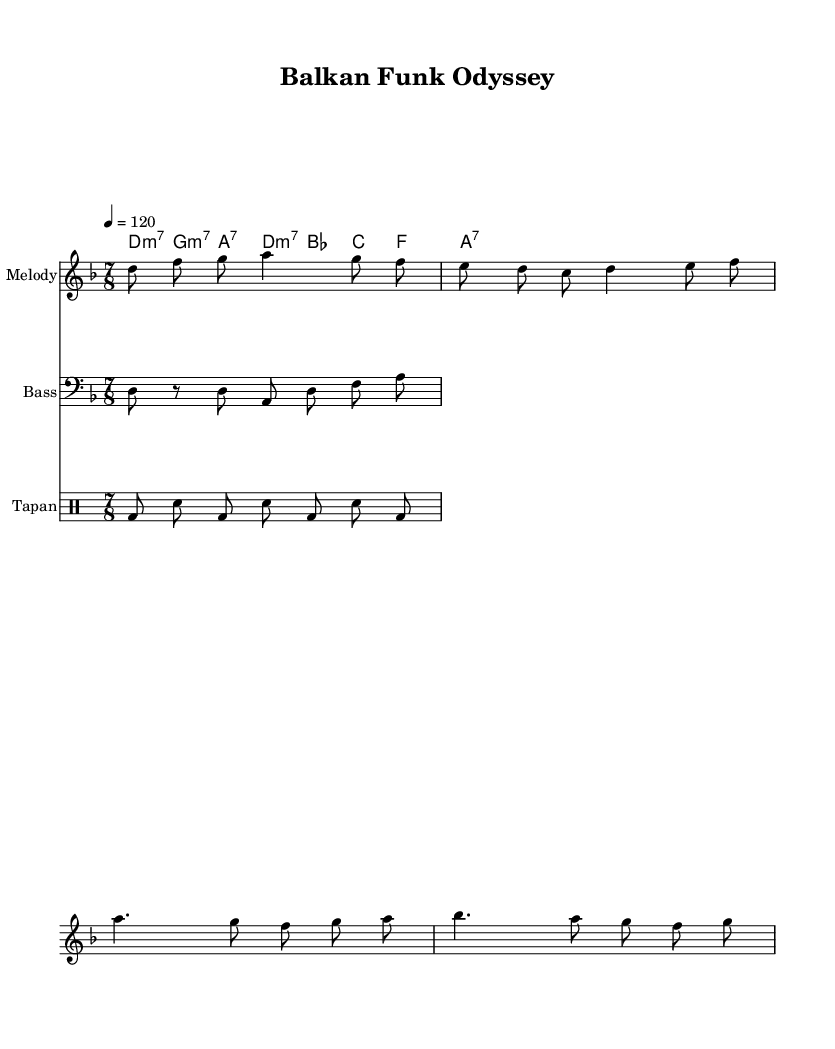What is the key signature of this music? The key signature indicated in the music is D minor, which typically has one flat (B flat) on the staff. This can be identified at the beginning of the score, where the sharps and flats are notated.
Answer: D minor What is the time signature of this piece? The time signature is shown as 7/8, which is specified in the beginning of the score. This indicates that there are seven eighth notes in each measure.
Answer: 7/8 What is the tempo marking for this composition? The tempo is specified as quarter note equals 120 beats per minute, which shows how fast the piece should be played. This information is usually found at the start of the piece, near the time signature.
Answer: 120 How many measures does the melody section contain? By counting the distinct groups of notes separated by the bar lines in the melody staff, we can see there are eight measures in total. This is counted by visually scanning the music for each vertical line marking the end of a measure.
Answer: 8 Which type of drum is used in the percussion part? The drum notation shows the use of the Tapan, which is a traditional Balkan drum. This can be identified by the notation used in the drum staff section for the percussion instrument.
Answer: Tapan What is the chord progression used in the harmonies section? The chord progression shown in the score is D minor 7, G minor 7, A dominant 7, and back to D minor 7. Each chord is listed in succession, indicating the harmonic structure of the piece.
Answer: D minor 7, G minor 7, A 7, D minor 7 What is the rhythmic pattern of the bass line? The bass line follows a 7/8 rhythm, indicated by the eighth notes in groups within the staff, where each grouping contributes to the overall 7/8 feel of the piece. This can be observed by analyzing the note lengths and placements.
Answer: 7/8 rhythm 